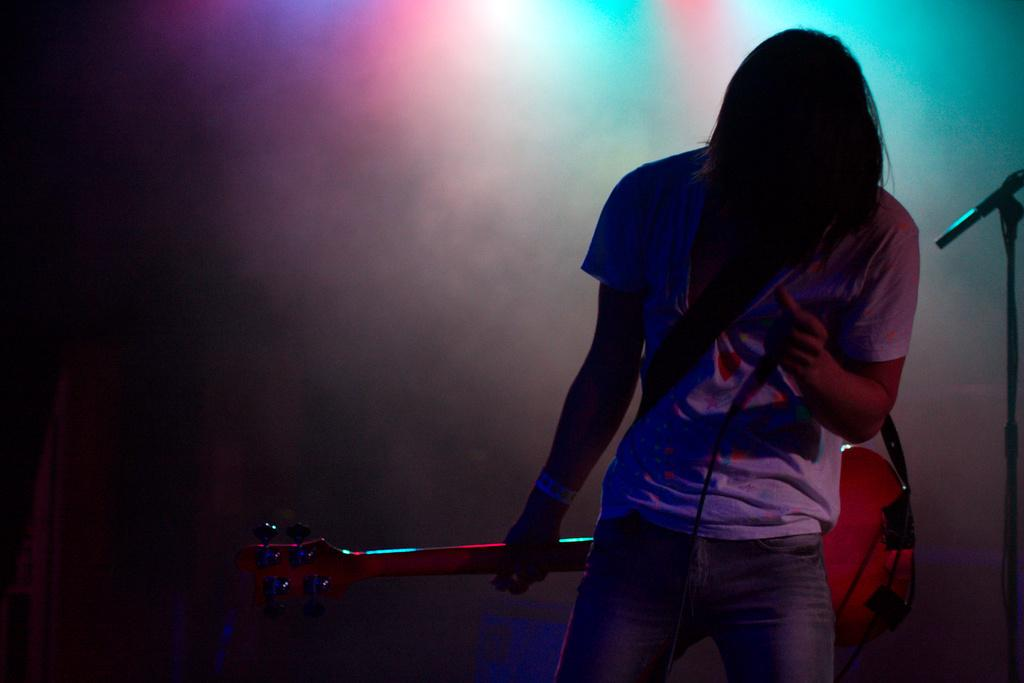What is the person in the image holding? The person is holding a guitar and a mic. What can be seen on the right side of the image? There is a mic stand on the right side of the image. What is visible in the background of the image? There is smoke and light in the background of the image. What type of vegetable is being used as a prop in the image? There is no vegetable present in the image. What nut is being cracked by the person in the image? There is no nut-cracking activity depicted in the image. 